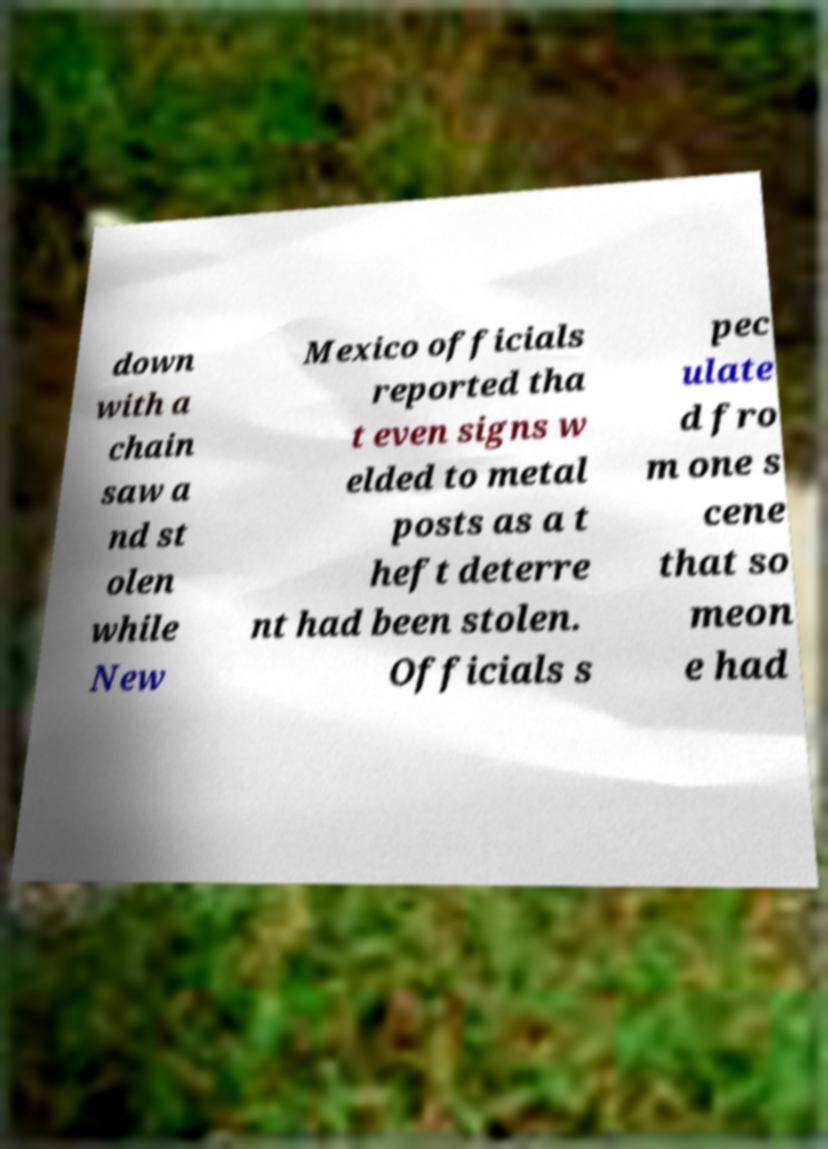Could you assist in decoding the text presented in this image and type it out clearly? down with a chain saw a nd st olen while New Mexico officials reported tha t even signs w elded to metal posts as a t heft deterre nt had been stolen. Officials s pec ulate d fro m one s cene that so meon e had 